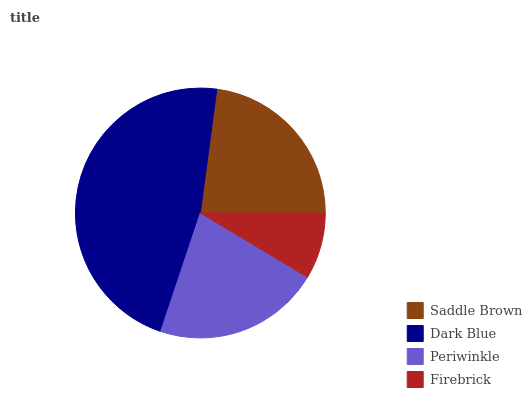Is Firebrick the minimum?
Answer yes or no. Yes. Is Dark Blue the maximum?
Answer yes or no. Yes. Is Periwinkle the minimum?
Answer yes or no. No. Is Periwinkle the maximum?
Answer yes or no. No. Is Dark Blue greater than Periwinkle?
Answer yes or no. Yes. Is Periwinkle less than Dark Blue?
Answer yes or no. Yes. Is Periwinkle greater than Dark Blue?
Answer yes or no. No. Is Dark Blue less than Periwinkle?
Answer yes or no. No. Is Saddle Brown the high median?
Answer yes or no. Yes. Is Periwinkle the low median?
Answer yes or no. Yes. Is Firebrick the high median?
Answer yes or no. No. Is Saddle Brown the low median?
Answer yes or no. No. 